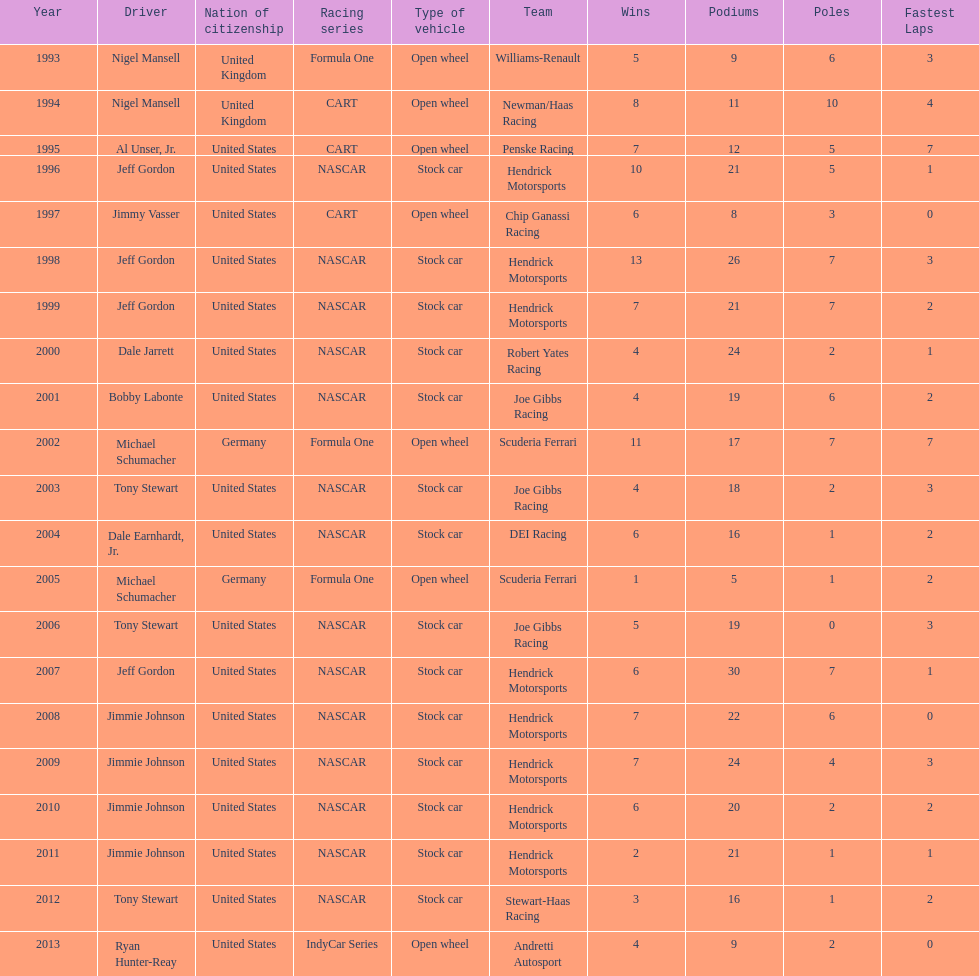Excluding nascar, what other racing series have drivers who have won espy awards participated in? Formula One, CART, IndyCar Series. 